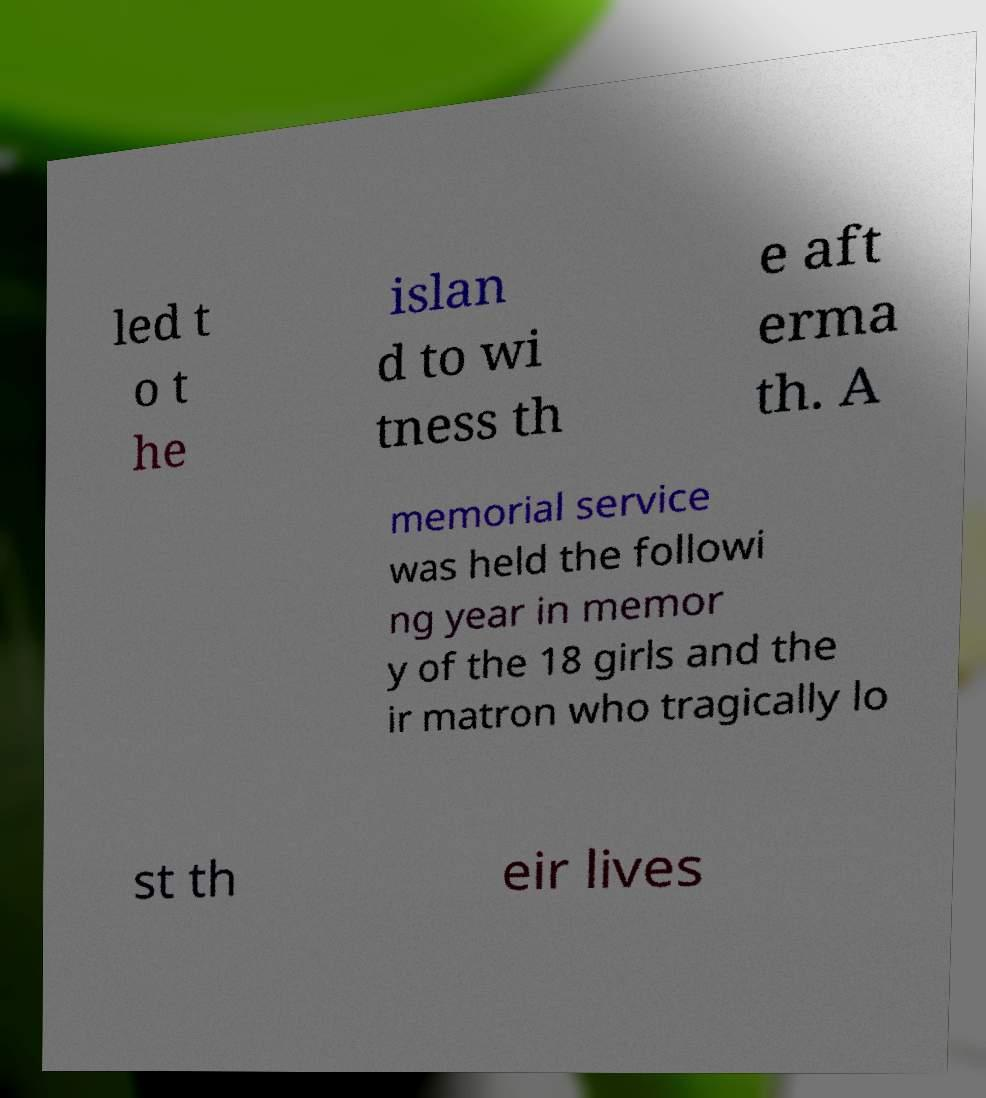Please identify and transcribe the text found in this image. led t o t he islan d to wi tness th e aft erma th. A memorial service was held the followi ng year in memor y of the 18 girls and the ir matron who tragically lo st th eir lives 